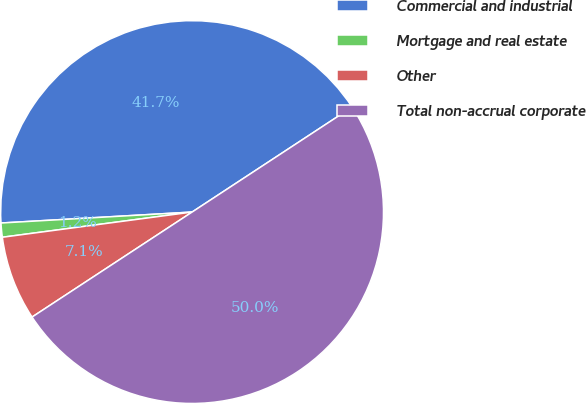Convert chart to OTSL. <chart><loc_0><loc_0><loc_500><loc_500><pie_chart><fcel>Commercial and industrial<fcel>Mortgage and real estate<fcel>Other<fcel>Total non-accrual corporate<nl><fcel>41.67%<fcel>1.19%<fcel>7.14%<fcel>50.0%<nl></chart> 